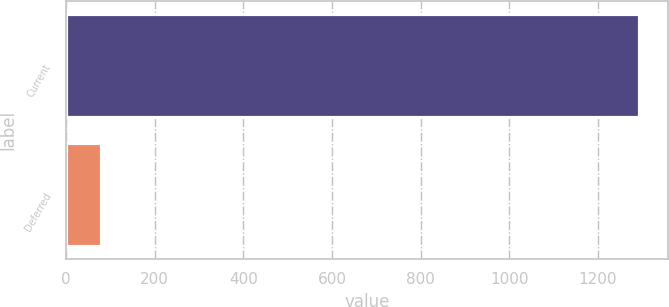Convert chart. <chart><loc_0><loc_0><loc_500><loc_500><bar_chart><fcel>Current<fcel>Deferred<nl><fcel>1293<fcel>78<nl></chart> 